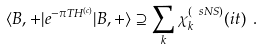Convert formula to latex. <formula><loc_0><loc_0><loc_500><loc_500>\langle B , + | e ^ { - \pi T H ^ { ( c ) } } | B , + \rangle \supseteq \sum _ { k } \chi ^ { ( \ s N S ) } _ { k } ( i t ) \ .</formula> 